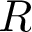Convert formula to latex. <formula><loc_0><loc_0><loc_500><loc_500>R</formula> 